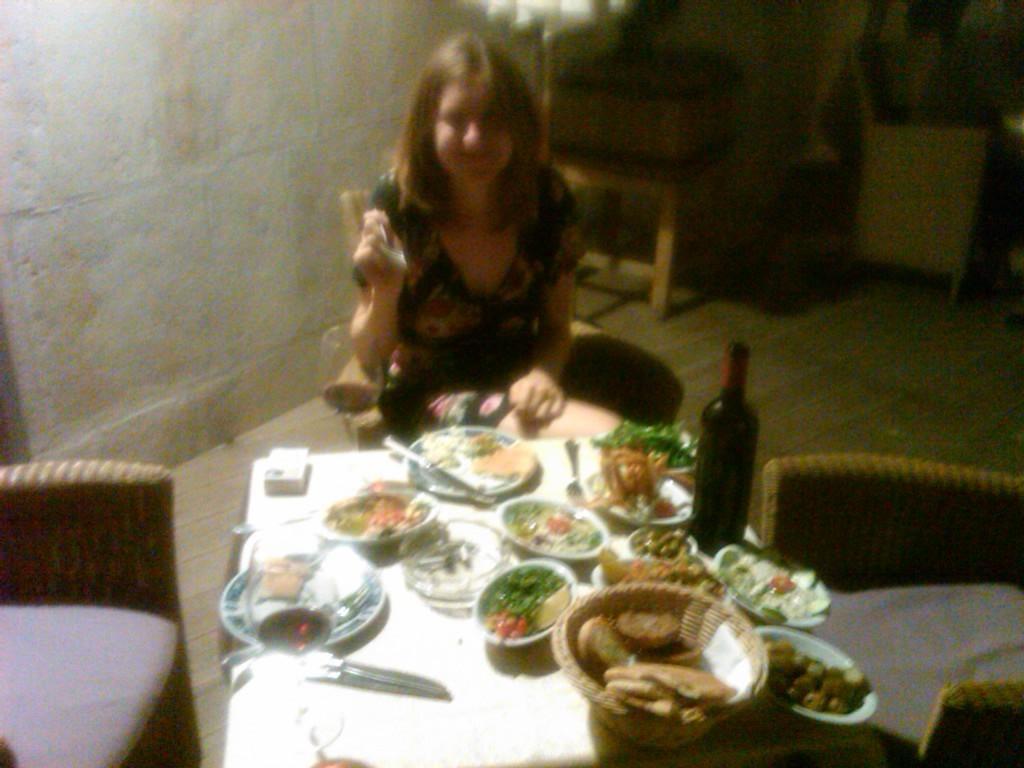How would you summarize this image in a sentence or two? This woman is sitting on a chair and holding spoon. In-front of this woman there is a table, on a table there is a basket, bowls, plates, bottle and food. 